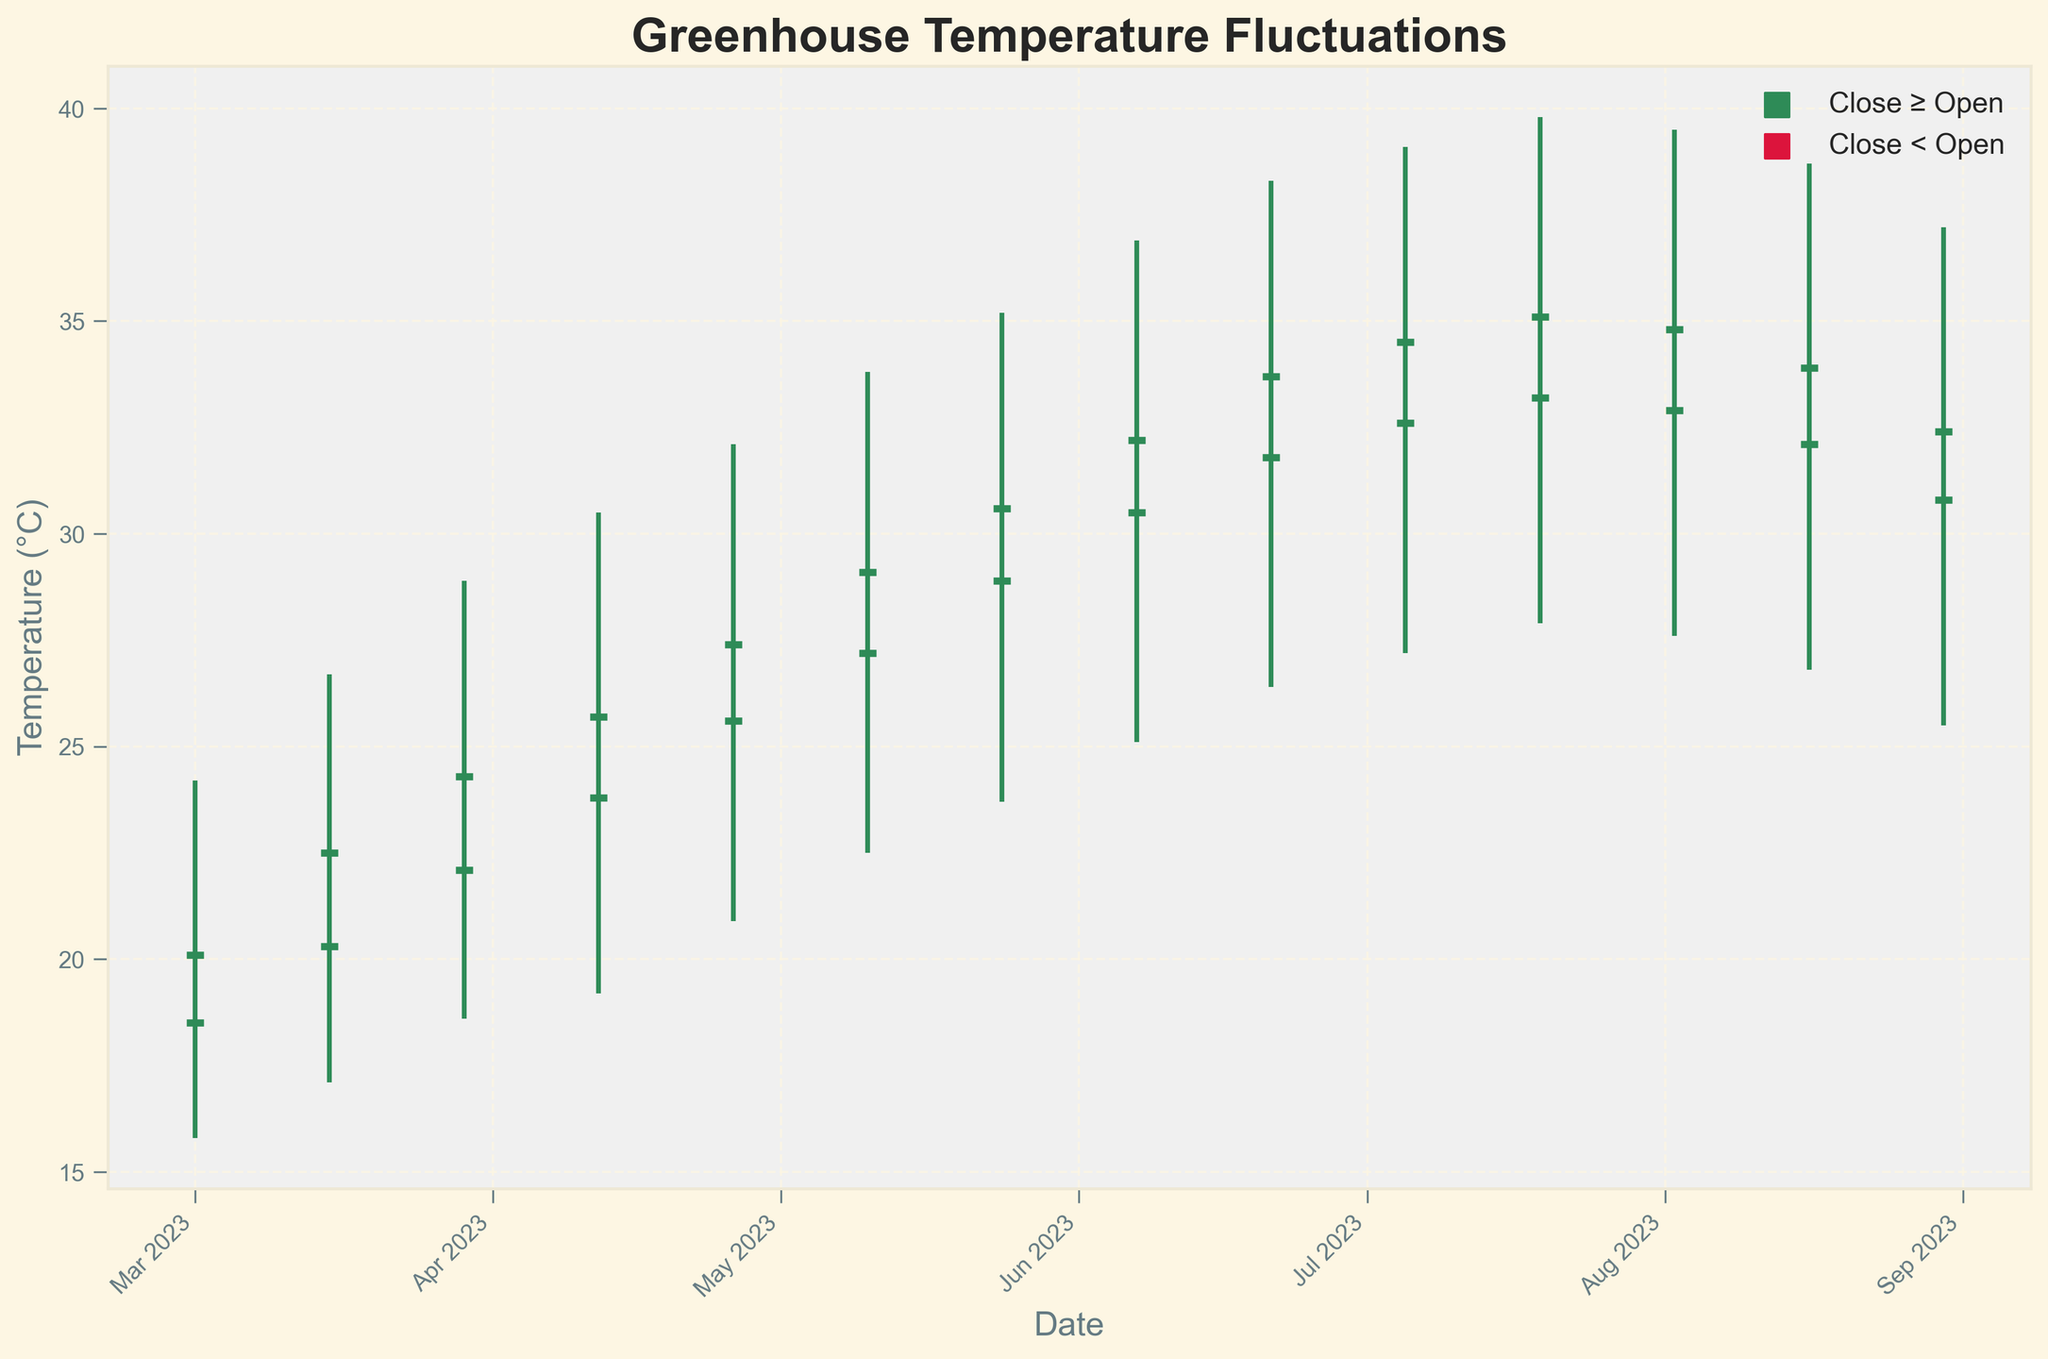What is the title of the chart? The title of the chart is displayed at the top, reading "Greenhouse Temperature Fluctuations".
Answer: Greenhouse Temperature Fluctuations How many data points are represented in the chart? Each data point corresponds to an entry in the dataset, and there are 13 entries.
Answer: 13 Which color represents the days when the closing temperature is higher than the opening temperature? The chart uses 'seagreen' color for the days where the closing temperature is higher than or equal to the opening temperature.
Answer: Seagreen How can you identify the highest temperature recorded in the chart? The highest temperature recorded is represented by the tallest vertical line; hovering around 39.8°C on July 19.
Answer: 39.8°C What was the closing temperature on May 24, 2023? May 24, 2023, is directly located and marked in the dataset, showing that the closing temperature was 30.6°C.
Answer: 30.6°C Comparing March 1, 2023, and March 15, 2023, which day had a higher high temperature? Referring to the high temperatures on the two dates, March 15 (26.7°C) was higher than March 1 (24.2°C).
Answer: March 15, 2023 Which month showed the most significant increase in overall temperature from the beginning to the end? By comparing the temperature shifts, July shows the most significant increase with an opening temperature of 32.6°C and a closing temperature of 35.1°C.
Answer: July What is the lowest temperature recorded on April 26, 2023? Referring to the 'Low' value on April 26, 2023, the lowest temperature recorded was 20.9°C.
Answer: 20.9°C How often did the closing temperature decrease compared to the opening temperature? Inspecting the colors, crimson-colored markers show when closing temperatures were lower than opening temperatures, which occurred on August 2, 16, and 30.
Answer: 3 times What is the average closing temperature in June 2023? Data for June 7 (32.2°C) and June 21 (33.7°C) are summed and divided by 2. The average is (32.2 + 33.7) / 2 = 32.95°C.
Answer: 32.95°C 